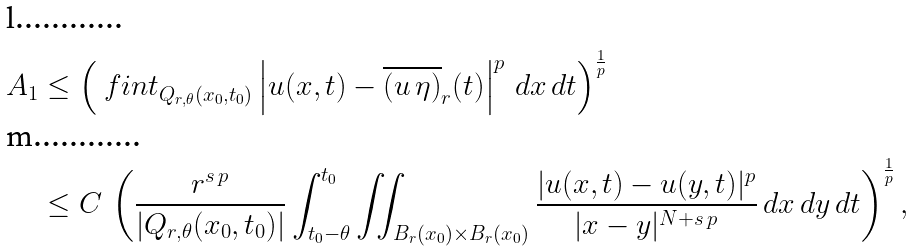<formula> <loc_0><loc_0><loc_500><loc_500>A _ { 1 } & \leq \left ( \ f i n t _ { Q _ { r , \theta } ( x _ { 0 } , t _ { 0 } ) } \left | u ( x , t ) - \overline { ( u \, \eta ) } _ { r } ( t ) \right | ^ { p } \, d x \, d t \right ) ^ { \frac { 1 } { p } } \\ & \leq C \, \left ( \frac { r ^ { s \, p } } { | Q _ { r , \theta } ( x _ { 0 } , t _ { 0 } ) | } \int _ { t _ { 0 } - \theta } ^ { t _ { 0 } } \iint _ { B _ { r } ( x _ { 0 } ) \times B _ { r } ( x _ { 0 } ) } \frac { | u ( x , t ) - u ( y , t ) | ^ { p } } { | x - y | ^ { N + s \, p } } \, d x \, d y \, d t \right ) ^ { \frac { 1 } { p } } ,</formula> 